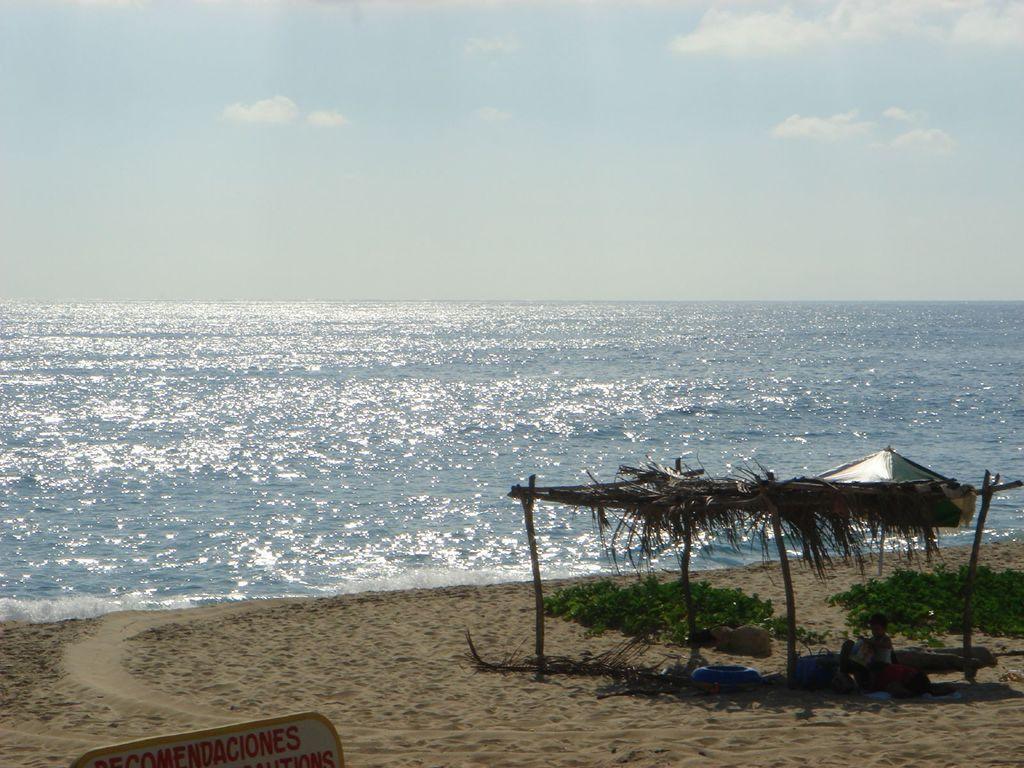Can you describe this image briefly? This picture is clicked outside the city. On the right there is a tent and we can see a person and some objects under the tent and we can see the small portion of the green grass and there is a board on which the text is printed. In the center there is a water body. In the background there is a sky. 